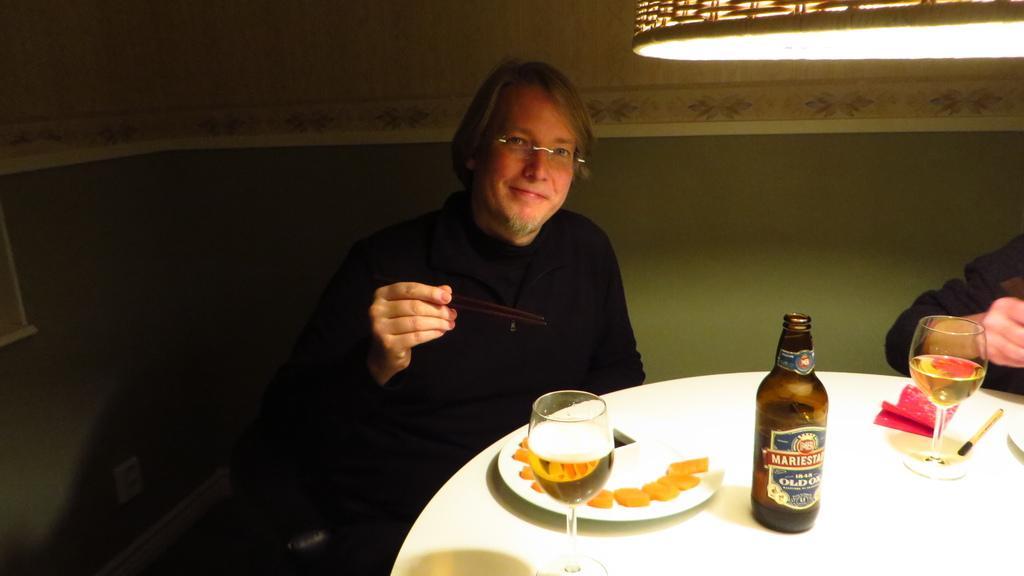Please provide a concise description of this image. A man wearing a specs and a black dress is holding a chop sticks and sitting on a sofa. In front of him there is a table. On the table there is a plate, wine glass, bottle, on the plate there are some food item. And there is a light on the right corner. In the background there is a wall. 